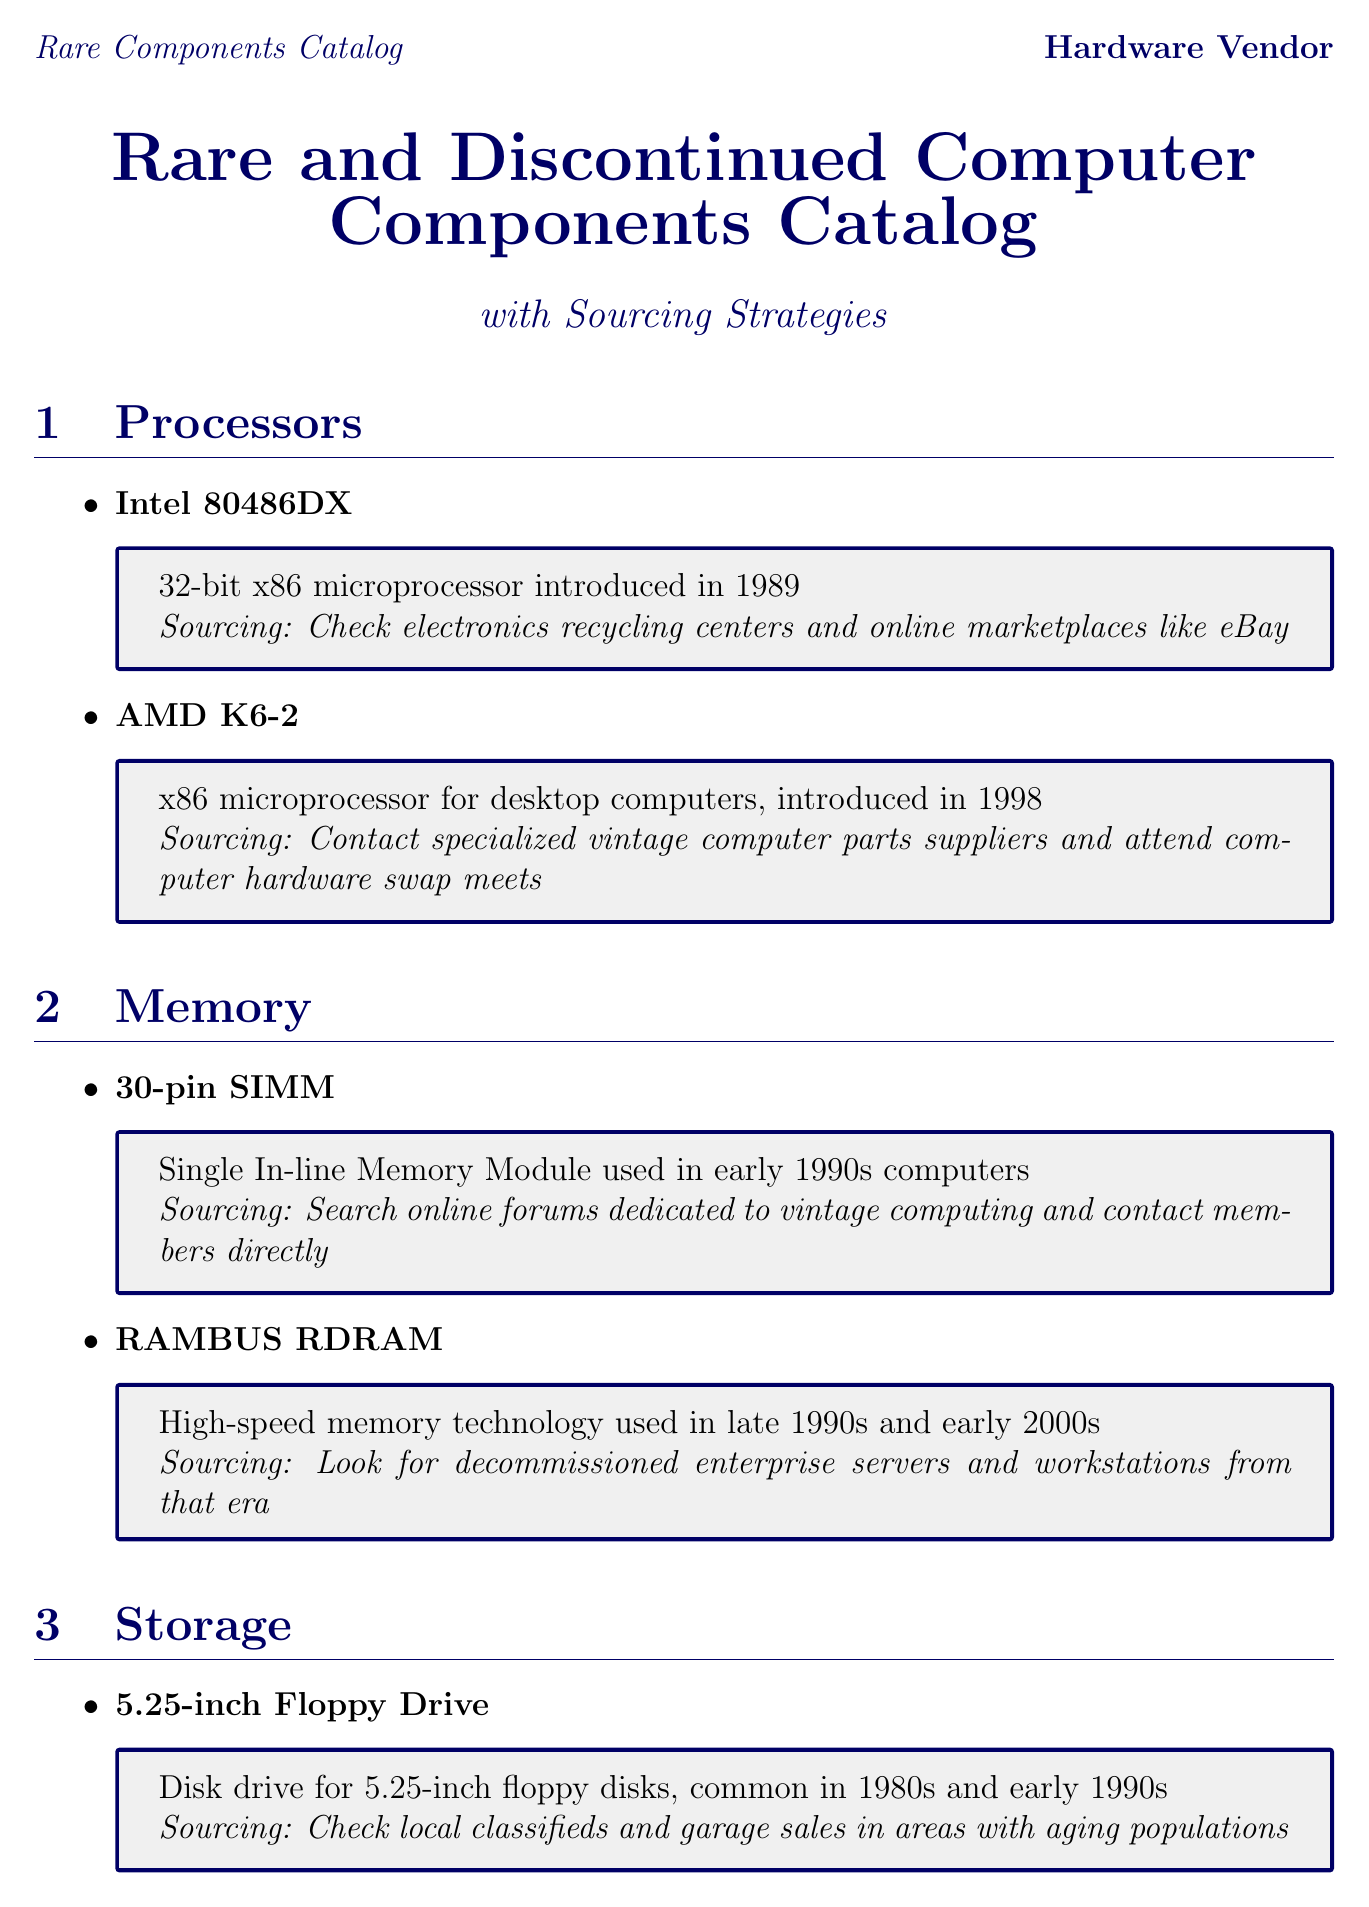what is the description of Intel 80486DX? The description provides details about the Intel 80486DX as a 32-bit x86 microprocessor introduced in 1989.
Answer: 32-bit x86 microprocessor introduced in 1989 where can you source a 5.25-inch Floppy Drive? The sourcing strategy for the 5.25-inch Floppy Drive includes checking local classifieds and garage sales in areas with aging populations.
Answer: Local classifieds and garage sales what is an example of a sourcing strategy for RAMBUS RDRAM? The document specifies looking for decommissioned enterprise servers and workstations as a sourcing strategy for RAMBUS RDRAM.
Answer: Decommissioned enterprise servers and workstations which component is described as a dial-up modem? The document identifies the US Robotics 56K Faxmodem as a dial-up modem popular in the late 1990s.
Answer: US Robotics 56K Faxmodem what tip is given for building relationships in sourcing? The sourcing tips include establishing connections with local e-waste facilities to get first pick of rare components before they're recycled.
Answer: Build relationships with e-waste recycling centers which graphics card is associated with retro gaming conventions? According to the document, the 3dfx Voodoo Graphics is associated with retro gaming conventions.
Answer: 3dfx Voodoo Graphics how many sourcing tips are provided in the document? The document lists five unique sourcing tips for obtaining rare computer components.
Answer: Five what year was the AMD K6-2 introduced? The document states that the AMD K6-2 was introduced in 1998.
Answer: 1998 